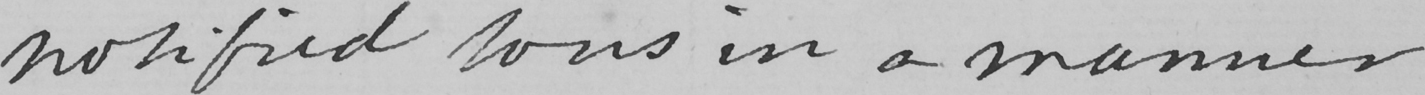What does this handwritten line say? notified thus in a manner 